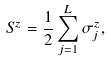Convert formula to latex. <formula><loc_0><loc_0><loc_500><loc_500>S ^ { z } = \frac { 1 } { 2 } \sum _ { j = 1 } ^ { L } \sigma _ { j } ^ { z } ,</formula> 